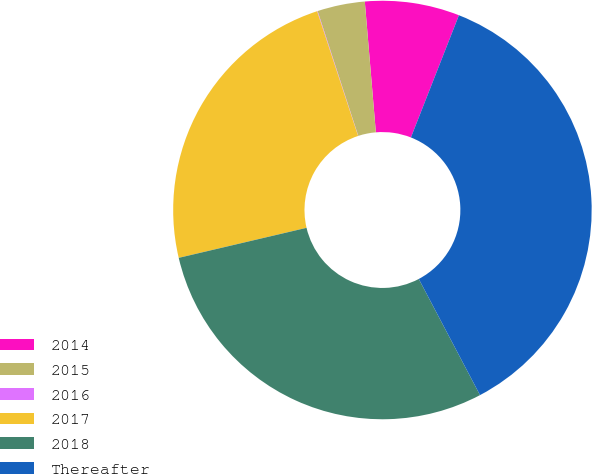Convert chart. <chart><loc_0><loc_0><loc_500><loc_500><pie_chart><fcel>2014<fcel>2015<fcel>2016<fcel>2017<fcel>2018<fcel>Thereafter<nl><fcel>7.3%<fcel>3.67%<fcel>0.04%<fcel>23.62%<fcel>29.05%<fcel>36.32%<nl></chart> 